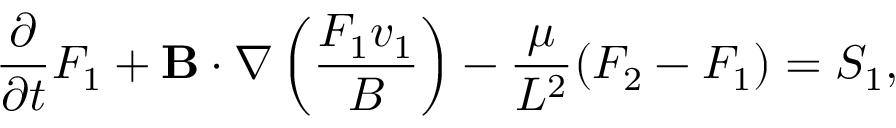Convert formula to latex. <formula><loc_0><loc_0><loc_500><loc_500>\frac { \partial } { \partial t } F _ { 1 } + { B } \cdot \nabla \left ( \frac { F _ { 1 } v _ { 1 } } { B } \right ) - \frac { \mu } { L ^ { 2 } } ( F _ { 2 } - F _ { 1 } ) = S _ { 1 } ,</formula> 